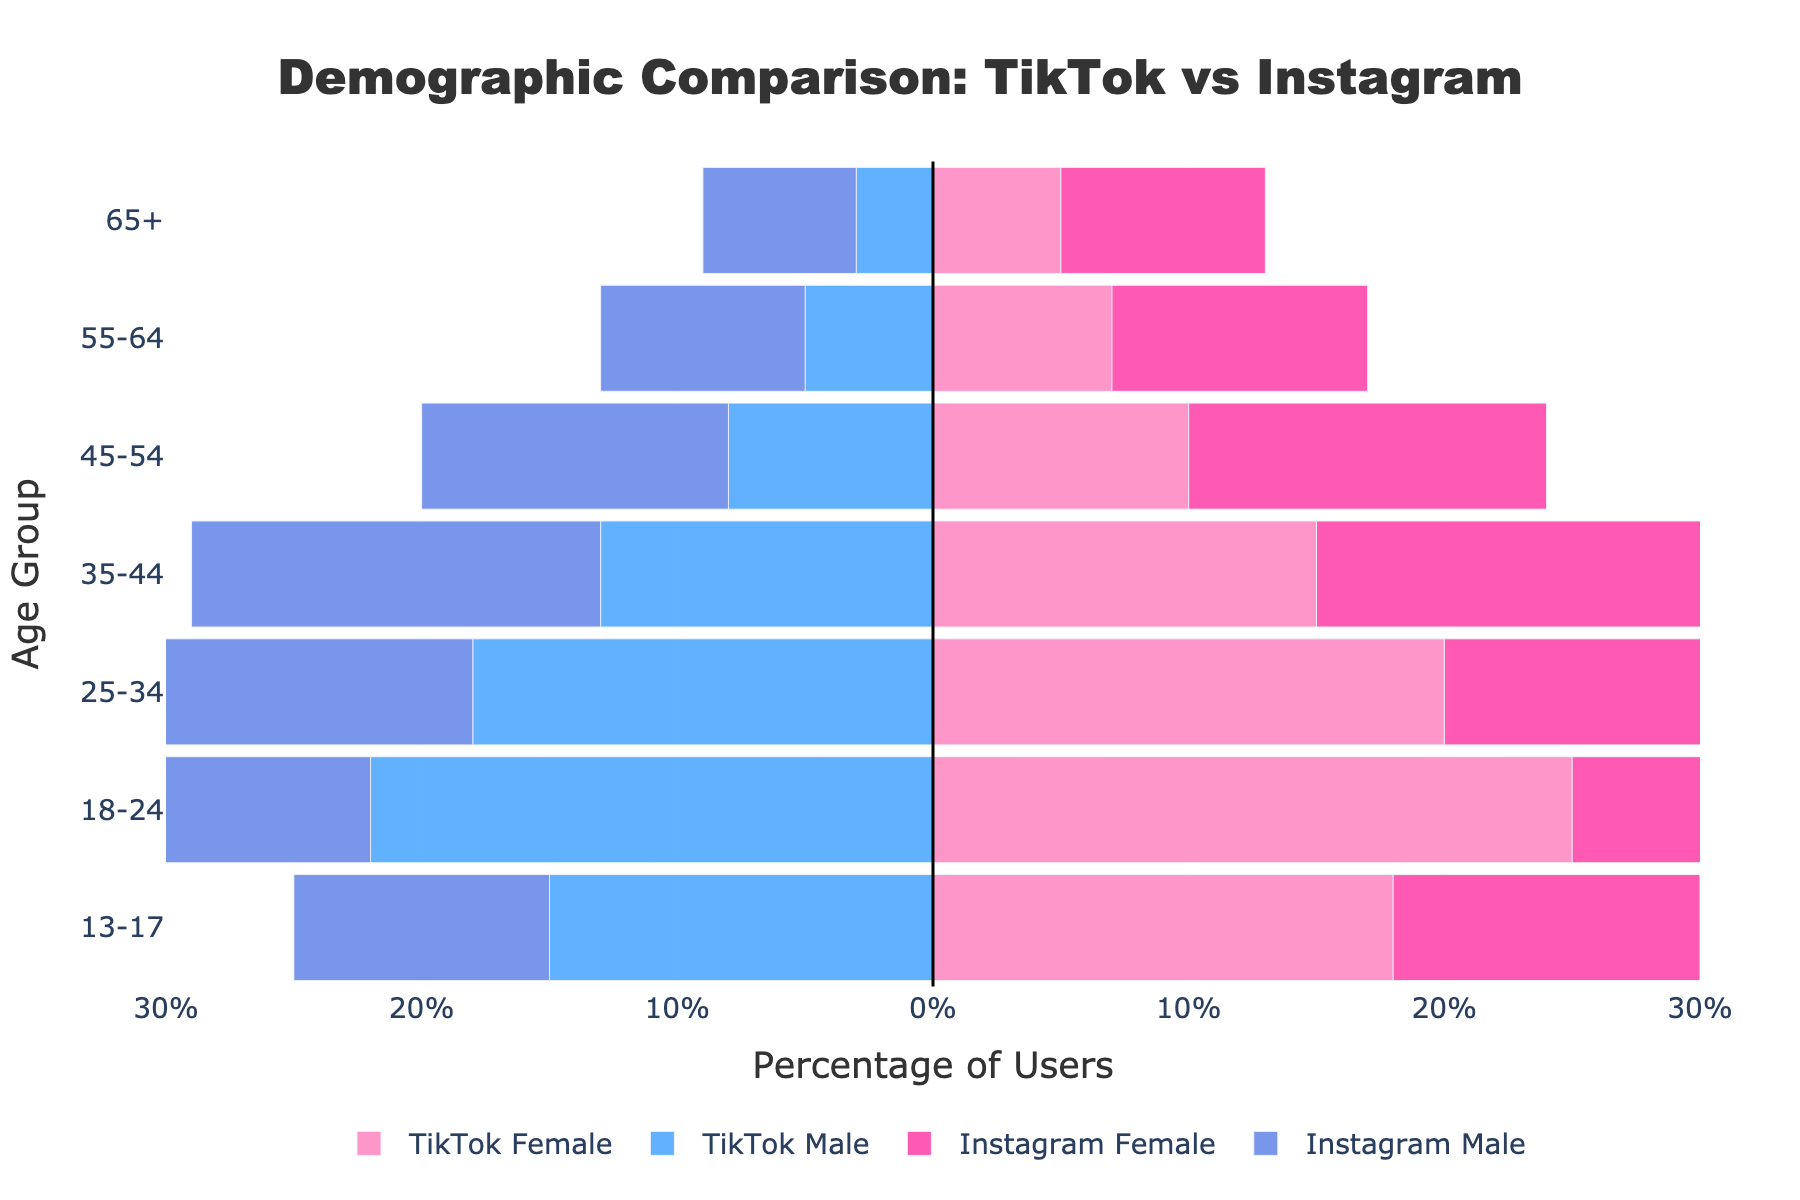What is the title of the figure? The title of the figure is prominently displayed at the top center of the plot. It states what the figure represents.
Answer: Demographic Comparison: TikTok vs Instagram Which age group has the highest percentage of TikTok Female users? Observe the bar lengths for TikTok Female users across all age groups and identify the one which extends the furthest to the right.
Answer: 18-24 How does the percentage of Instagram Male users aged 35-44 compare to TikTok Male users in the same age group? Compare the lengths of the bars for Instagram Male and TikTok Male for the 35-44 age group. The Instagram Male bar extends further to the left.
Answer: Instagram Male users have a higher percentage Which platform has a higher percentage of users aged 55-64 for both males and females combined? Sum the percentage of male and female users for both TikTok and Instagram in the 55-64 age group and compare.
Answer: Instagram For TikTok, is there a significant difference in the percentage of male and female users aged 13-17? Compare the lengths of the male and female bars for TikTok in the 13-17 age group. The lengths are close but not equal.
Answer: Yes, females are slightly more Looking at the 65+ age group, which platform has a more balanced gender distribution? Balance is achieved when the lengths of the male and female bars are similar. Compare TikTok's and Instagram's bars for the 65+ group.
Answer: Instagram What is the combined percentage of TikTok users aged 18-24? Add the percentages of TikTok Male and TikTok Female users in the 18-24 age group.
Answer: 47% Between the 25-34 and 35-44 age groups, which has the larger gap between Instagram Male and Female users? Calculate the absolute difference between male and female percentages for each age group on Instagram and compare.
Answer: 35-44 How does the distribution of Instagram users aged 45-54 compare to users aged 25-34? Compare the percentage bars for Instagram users in both age groups for both genders to see how the distribution shifts.
Answer: 25-34 has higher percentages for both genders Which gender shows a larger difference in user percentages between TikTok and Instagram in the 18-24 age group? Calculate the difference in percentages for both male and female users between TikTok and Instagram in the 18-24 age group.
Answer: Female 